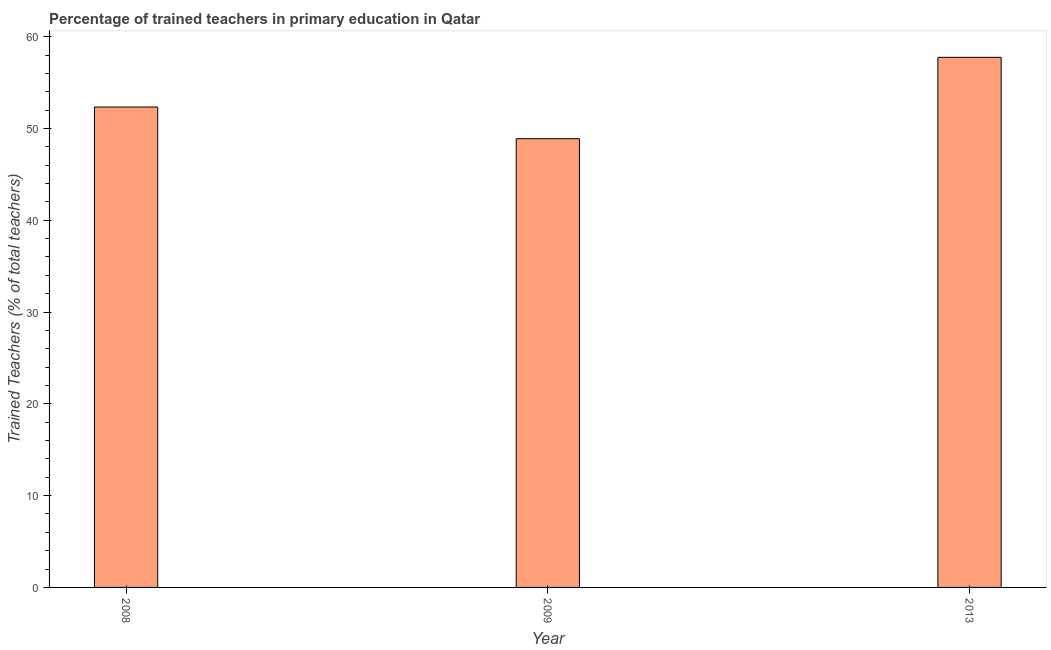What is the title of the graph?
Ensure brevity in your answer.  Percentage of trained teachers in primary education in Qatar. What is the label or title of the X-axis?
Ensure brevity in your answer.  Year. What is the label or title of the Y-axis?
Give a very brief answer. Trained Teachers (% of total teachers). What is the percentage of trained teachers in 2013?
Offer a terse response. 57.75. Across all years, what is the maximum percentage of trained teachers?
Give a very brief answer. 57.75. Across all years, what is the minimum percentage of trained teachers?
Your response must be concise. 48.89. In which year was the percentage of trained teachers maximum?
Make the answer very short. 2013. In which year was the percentage of trained teachers minimum?
Your response must be concise. 2009. What is the sum of the percentage of trained teachers?
Give a very brief answer. 158.97. What is the difference between the percentage of trained teachers in 2008 and 2013?
Provide a succinct answer. -5.41. What is the average percentage of trained teachers per year?
Provide a succinct answer. 52.99. What is the median percentage of trained teachers?
Make the answer very short. 52.34. Do a majority of the years between 2009 and 2013 (inclusive) have percentage of trained teachers greater than 36 %?
Offer a very short reply. Yes. What is the ratio of the percentage of trained teachers in 2008 to that in 2013?
Your answer should be compact. 0.91. Is the percentage of trained teachers in 2008 less than that in 2009?
Ensure brevity in your answer.  No. Is the difference between the percentage of trained teachers in 2008 and 2009 greater than the difference between any two years?
Make the answer very short. No. What is the difference between the highest and the second highest percentage of trained teachers?
Keep it short and to the point. 5.41. Is the sum of the percentage of trained teachers in 2008 and 2013 greater than the maximum percentage of trained teachers across all years?
Make the answer very short. Yes. What is the difference between the highest and the lowest percentage of trained teachers?
Provide a short and direct response. 8.86. In how many years, is the percentage of trained teachers greater than the average percentage of trained teachers taken over all years?
Your answer should be very brief. 1. How many bars are there?
Your answer should be very brief. 3. Are all the bars in the graph horizontal?
Give a very brief answer. No. What is the Trained Teachers (% of total teachers) of 2008?
Your answer should be compact. 52.34. What is the Trained Teachers (% of total teachers) of 2009?
Your answer should be very brief. 48.89. What is the Trained Teachers (% of total teachers) of 2013?
Ensure brevity in your answer.  57.75. What is the difference between the Trained Teachers (% of total teachers) in 2008 and 2009?
Your answer should be very brief. 3.45. What is the difference between the Trained Teachers (% of total teachers) in 2008 and 2013?
Your answer should be compact. -5.41. What is the difference between the Trained Teachers (% of total teachers) in 2009 and 2013?
Offer a terse response. -8.86. What is the ratio of the Trained Teachers (% of total teachers) in 2008 to that in 2009?
Your response must be concise. 1.07. What is the ratio of the Trained Teachers (% of total teachers) in 2008 to that in 2013?
Give a very brief answer. 0.91. What is the ratio of the Trained Teachers (% of total teachers) in 2009 to that in 2013?
Keep it short and to the point. 0.85. 